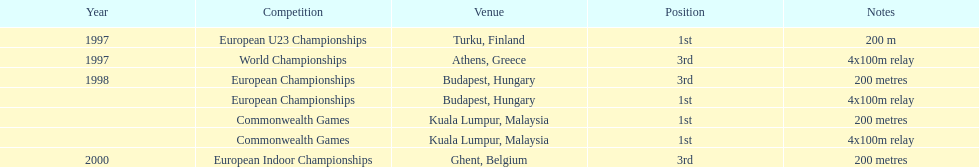Can you parse all the data within this table? {'header': ['Year', 'Competition', 'Venue', 'Position', 'Notes'], 'rows': [['1997', 'European U23 Championships', 'Turku, Finland', '1st', '200 m'], ['1997', 'World Championships', 'Athens, Greece', '3rd', '4x100m relay'], ['1998', 'European Championships', 'Budapest, Hungary', '3rd', '200 metres'], ['', 'European Championships', 'Budapest, Hungary', '1st', '4x100m relay'], ['', 'Commonwealth Games', 'Kuala Lumpur, Malaysia', '1st', '200 metres'], ['', 'Commonwealth Games', 'Kuala Lumpur, Malaysia', '1st', '4x100m relay'], ['2000', 'European Indoor Championships', 'Ghent, Belgium', '3rd', '200 metres']]} List the competitions that have the same relay as world championships from athens, greece. European Championships, Commonwealth Games. 